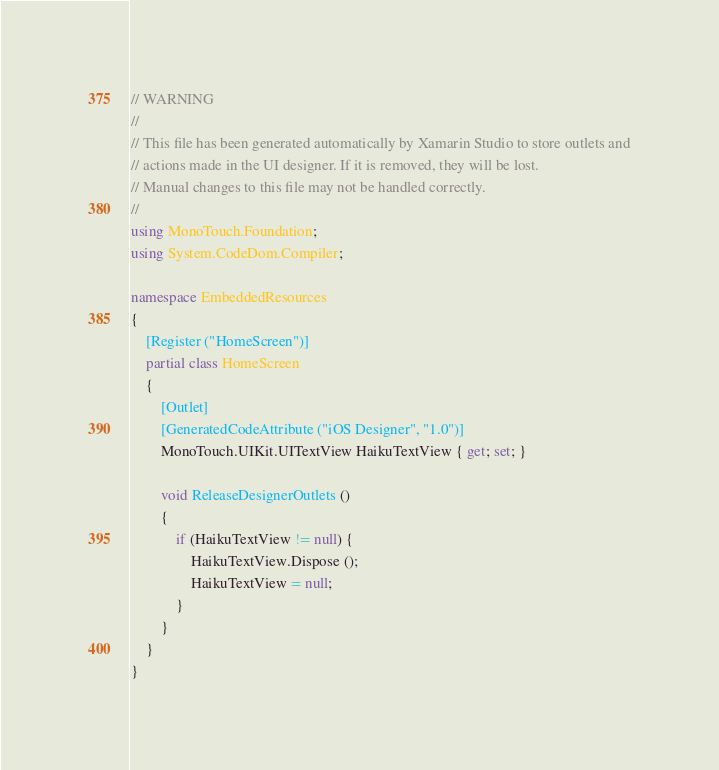<code> <loc_0><loc_0><loc_500><loc_500><_C#_>// WARNING
//
// This file has been generated automatically by Xamarin Studio to store outlets and
// actions made in the UI designer. If it is removed, they will be lost.
// Manual changes to this file may not be handled correctly.
//
using MonoTouch.Foundation;
using System.CodeDom.Compiler;

namespace EmbeddedResources
{
	[Register ("HomeScreen")]
	partial class HomeScreen
	{
		[Outlet]
		[GeneratedCodeAttribute ("iOS Designer", "1.0")]
		MonoTouch.UIKit.UITextView HaikuTextView { get; set; }
		
		void ReleaseDesignerOutlets ()
		{
			if (HaikuTextView != null) {
				HaikuTextView.Dispose ();
				HaikuTextView = null;
			}
		}
	}
}
</code> 